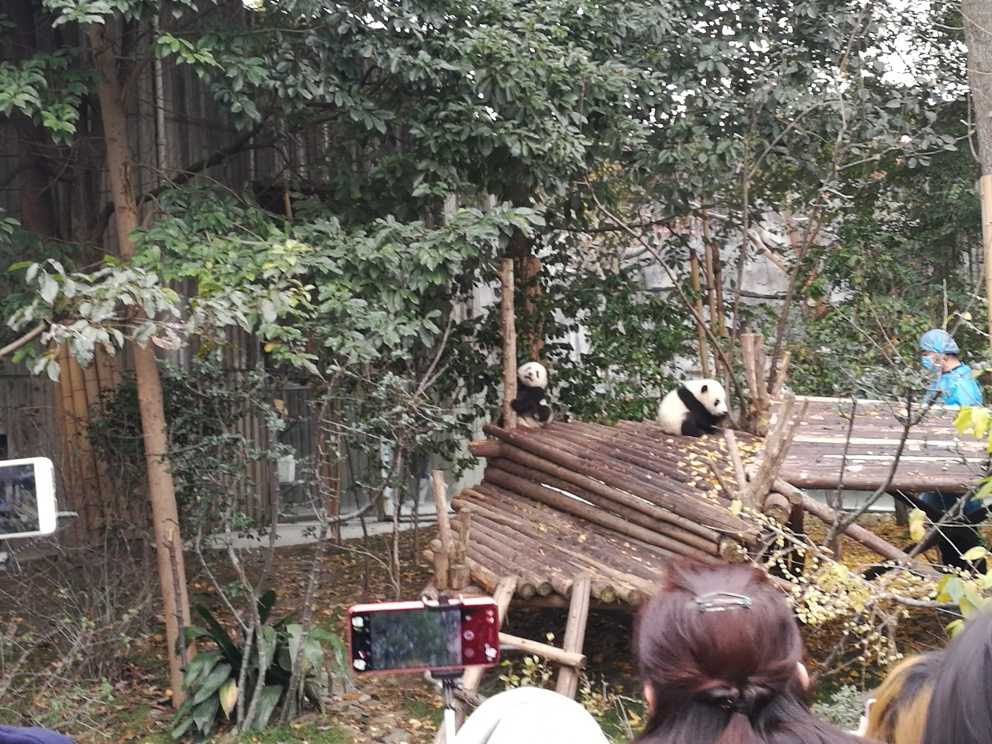Are there any quality issues with this image? Yes, there are several quality issues with this image. The overall focus is not sharp, making the finer details of the scene somewhat blurry. There's also noticeable visual noise, likely due to low lighting conditions or a high ISO setting used during shooting. Furthermore, the composition is slightly crowded with obstruction from the spectators in the foreground, which distracts from the main subjects, the pandas. The exposure could also be improved for better balance between light and shadow. 